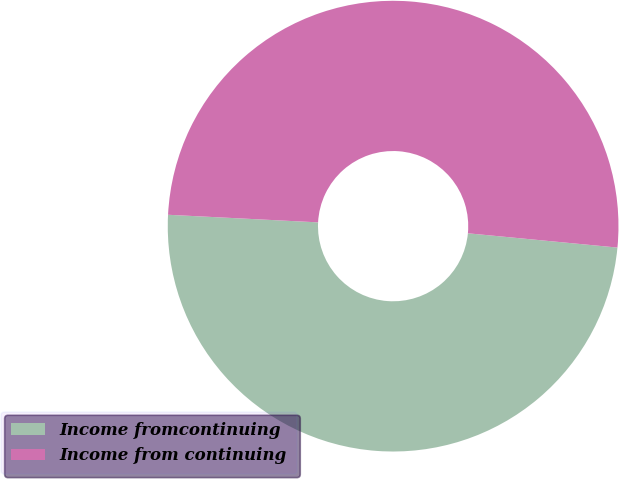Convert chart to OTSL. <chart><loc_0><loc_0><loc_500><loc_500><pie_chart><fcel>Income fromcontinuing<fcel>Income from continuing<nl><fcel>49.29%<fcel>50.71%<nl></chart> 